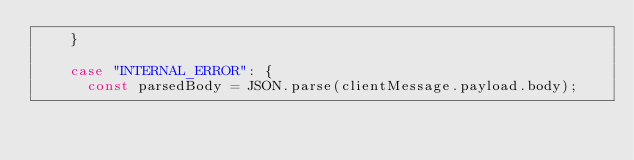<code> <loc_0><loc_0><loc_500><loc_500><_JavaScript_>    }

    case "INTERNAL_ERROR": {
      const parsedBody = JSON.parse(clientMessage.payload.body);
</code> 